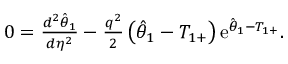<formula> <loc_0><loc_0><loc_500><loc_500>\begin{array} { r } { 0 = \frac { d ^ { 2 } \hat { \theta } _ { 1 } } { d \eta ^ { 2 } } - \frac { q ^ { 2 } } { 2 } \left ( \hat { \theta } _ { 1 } - T _ { 1 + } \right ) e ^ { \hat { \theta } _ { 1 } - T _ { 1 + } } . } \end{array}</formula> 